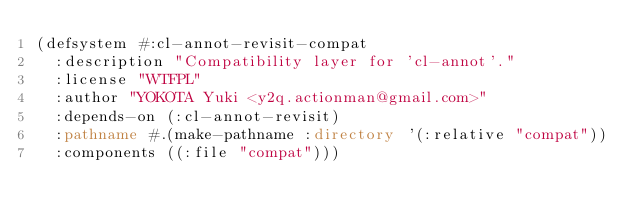Convert code to text. <code><loc_0><loc_0><loc_500><loc_500><_Lisp_>(defsystem #:cl-annot-revisit-compat
  :description "Compatibility layer for 'cl-annot'."
  :license "WTFPL"
  :author "YOKOTA Yuki <y2q.actionman@gmail.com>"
  :depends-on (:cl-annot-revisit)
  :pathname #.(make-pathname :directory '(:relative "compat"))
  :components ((:file "compat")))
</code> 